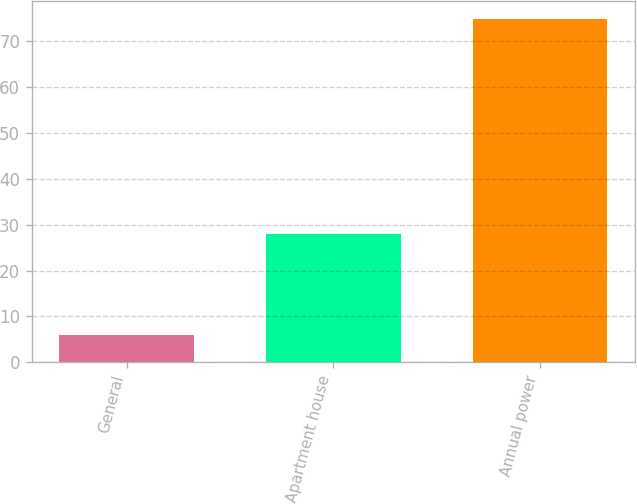Convert chart to OTSL. <chart><loc_0><loc_0><loc_500><loc_500><bar_chart><fcel>General<fcel>Apartment house<fcel>Annual power<nl><fcel>6<fcel>28<fcel>75<nl></chart> 